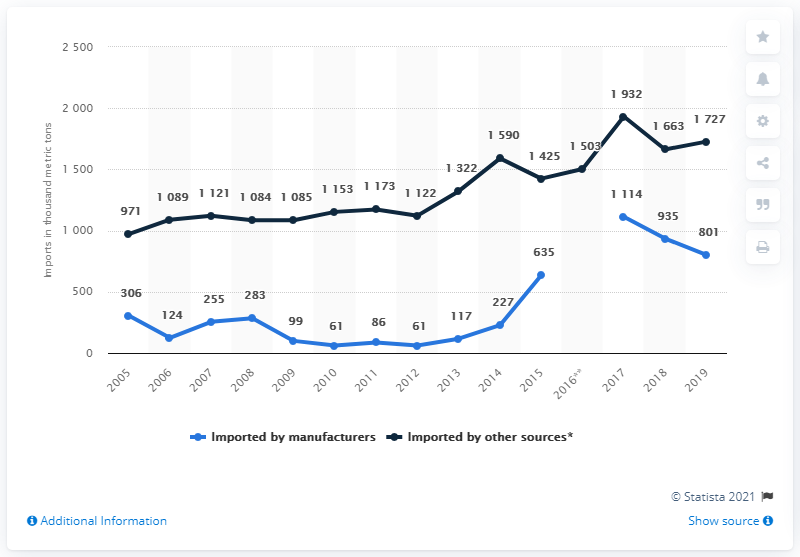Mention a couple of crucial points in this snapshot. In 2012, 61,000 metric tons of cement was imported into Great Britain by manufacturers. In 2005, the difference between the amount of cement imported by manufacturers and other sources was at its minimum. 